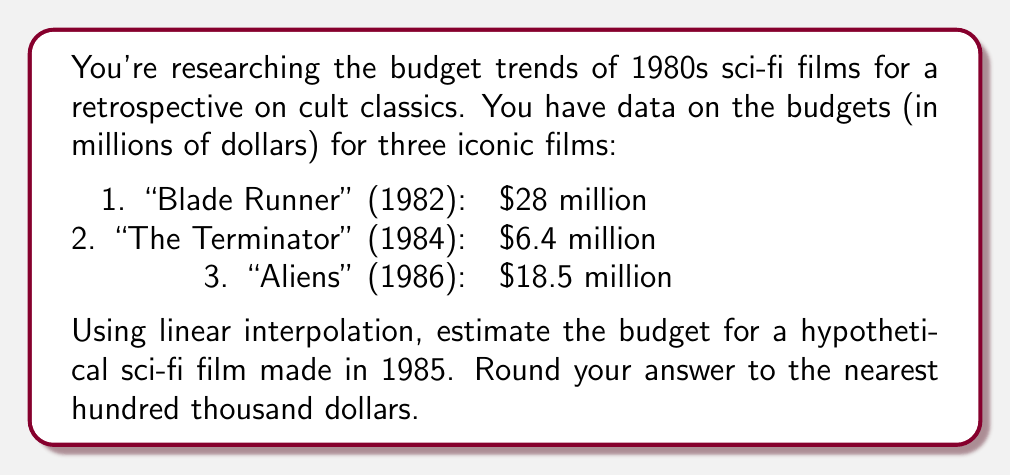Teach me how to tackle this problem. To solve this problem, we'll use linear interpolation between "The Terminator" (1984) and "Aliens" (1986), as 1985 falls between these two years.

Let's define our variables:
$x_1 = 1984$, $y_1 = 6.4$ (The Terminator)
$x_2 = 1986$, $y_2 = 18.5$ (Aliens)
$x = 1985$ (Our target year)

The linear interpolation formula is:

$$y = y_1 + \frac{(x - x_1)(y_2 - y_1)}{(x_2 - x_1)}$$

Plugging in our values:

$$y = 6.4 + \frac{(1985 - 1984)(18.5 - 6.4)}{(1986 - 1984)}$$

$$y = 6.4 + \frac{1 \times 12.1}{2}$$

$$y = 6.4 + 6.05$$

$$y = 12.45$$

Therefore, the estimated budget for a sci-fi film made in 1985 is $12.45 million.

Rounding to the nearest hundred thousand dollars:

$$12.45 \text{ million} \approx 12.5 \text{ million}$$
Answer: $12.5 million 